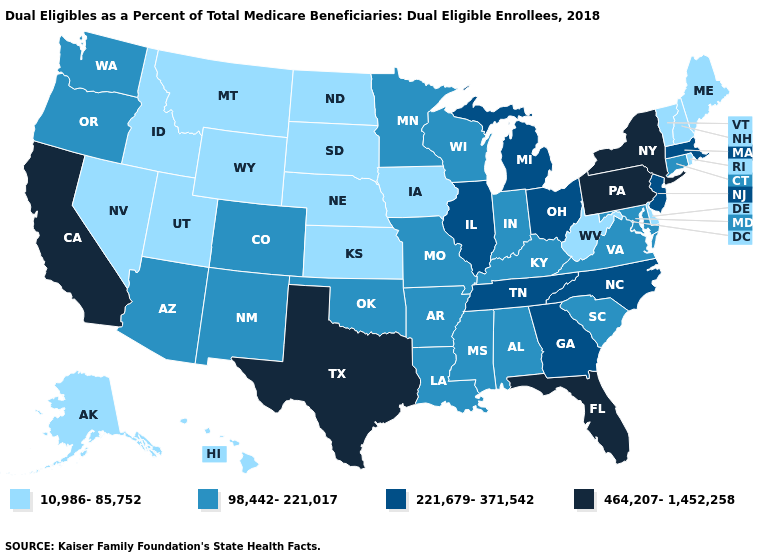Name the states that have a value in the range 221,679-371,542?
Answer briefly. Georgia, Illinois, Massachusetts, Michigan, New Jersey, North Carolina, Ohio, Tennessee. Does the map have missing data?
Short answer required. No. Among the states that border Colorado , which have the highest value?
Keep it brief. Arizona, New Mexico, Oklahoma. What is the highest value in the USA?
Give a very brief answer. 464,207-1,452,258. What is the lowest value in the South?
Quick response, please. 10,986-85,752. What is the lowest value in the West?
Keep it brief. 10,986-85,752. What is the value of Alaska?
Answer briefly. 10,986-85,752. Among the states that border North Carolina , which have the highest value?
Keep it brief. Georgia, Tennessee. What is the value of Delaware?
Answer briefly. 10,986-85,752. What is the value of New York?
Concise answer only. 464,207-1,452,258. Which states have the highest value in the USA?
Concise answer only. California, Florida, New York, Pennsylvania, Texas. Name the states that have a value in the range 221,679-371,542?
Write a very short answer. Georgia, Illinois, Massachusetts, Michigan, New Jersey, North Carolina, Ohio, Tennessee. What is the value of West Virginia?
Concise answer only. 10,986-85,752. Name the states that have a value in the range 221,679-371,542?
Answer briefly. Georgia, Illinois, Massachusetts, Michigan, New Jersey, North Carolina, Ohio, Tennessee. What is the value of Vermont?
Quick response, please. 10,986-85,752. 